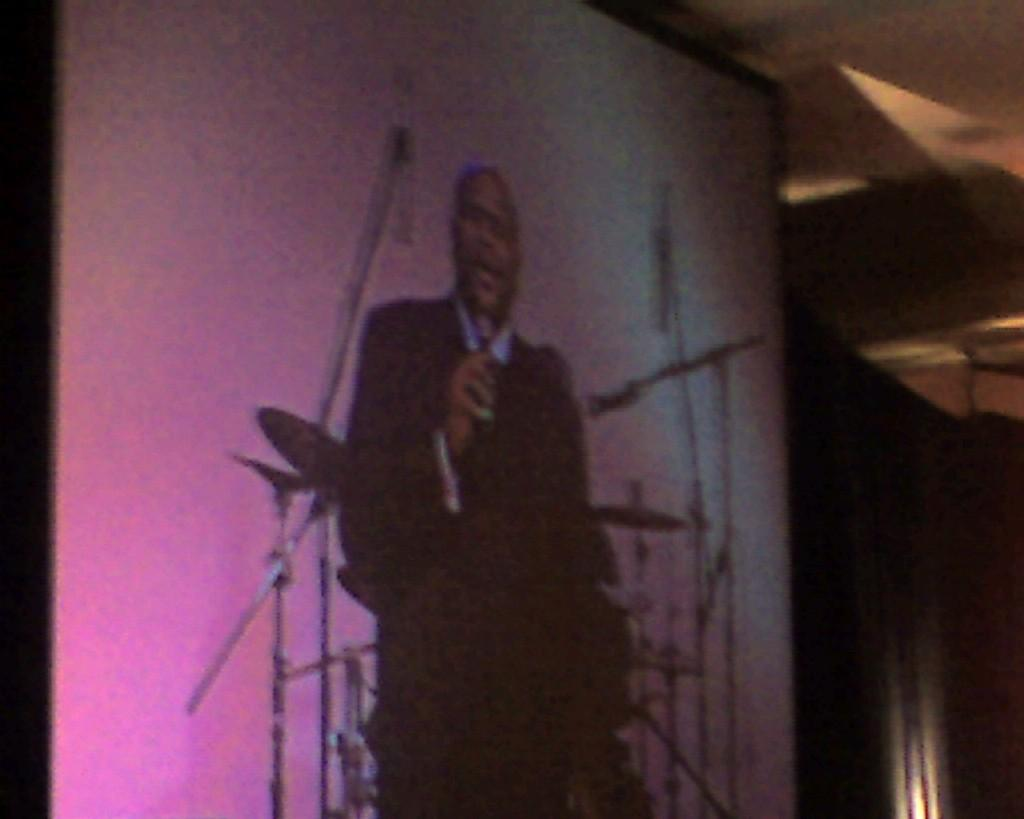What is the main object in the image? There is a screen in the image. What is happening on the screen? A man is standing on the screen. What can be seen in the background of the image? There are musical instruments in the background of the image. How does the man's daughter help him sort the musical instruments in the image? There is no mention of a daughter in the image, and the man is standing on the screen, not sorting musical instruments. 